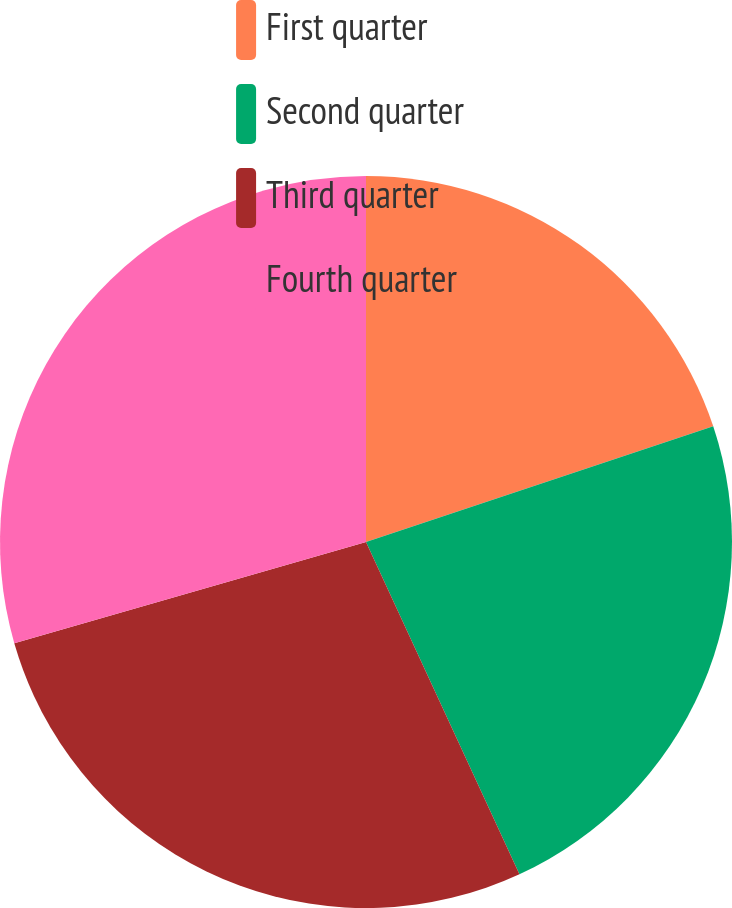Convert chart. <chart><loc_0><loc_0><loc_500><loc_500><pie_chart><fcel>First quarter<fcel>Second quarter<fcel>Third quarter<fcel>Fourth quarter<nl><fcel>19.88%<fcel>23.23%<fcel>27.42%<fcel>29.46%<nl></chart> 